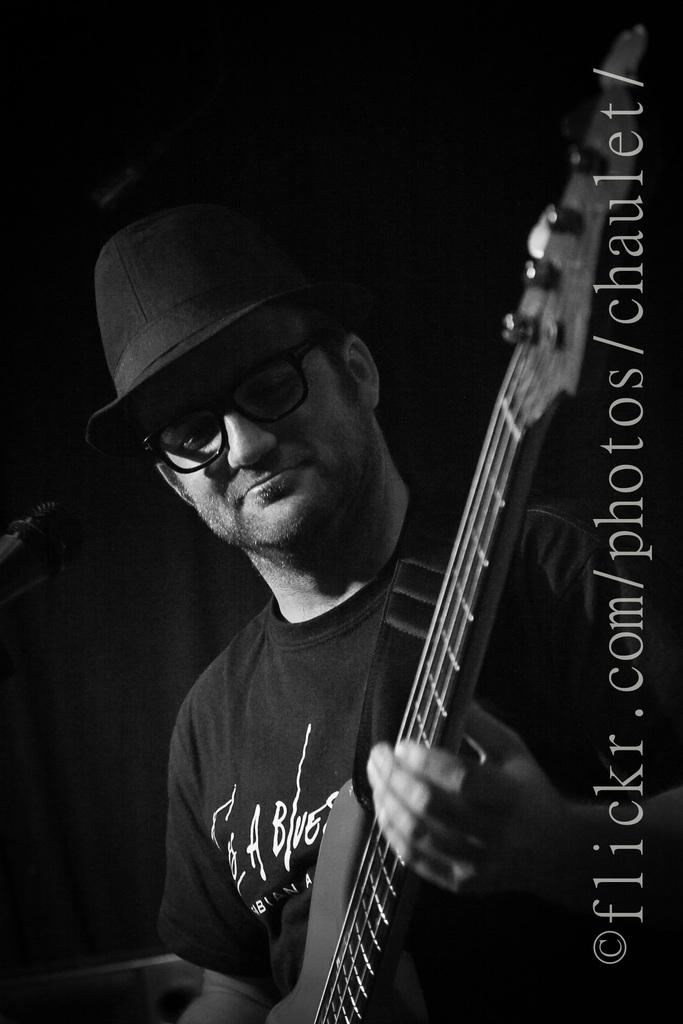What is the man in the image holding? The man is holding a guitar. What accessories is the man wearing in the image? The man is wearing spectacles and a hat. What can be seen in the background of the image? There is a black curtain in the background of the image. What is the weight of the crib in the image? There is no crib present in the image, so it's not possible to determine its weight. 